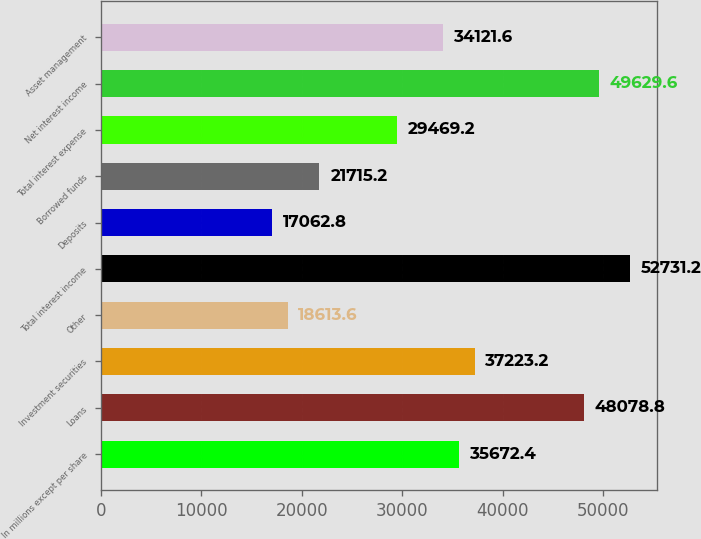<chart> <loc_0><loc_0><loc_500><loc_500><bar_chart><fcel>In millions except per share<fcel>Loans<fcel>Investment securities<fcel>Other<fcel>Total interest income<fcel>Deposits<fcel>Borrowed funds<fcel>Total interest expense<fcel>Net interest income<fcel>Asset management<nl><fcel>35672.4<fcel>48078.8<fcel>37223.2<fcel>18613.6<fcel>52731.2<fcel>17062.8<fcel>21715.2<fcel>29469.2<fcel>49629.6<fcel>34121.6<nl></chart> 